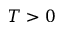<formula> <loc_0><loc_0><loc_500><loc_500>T > 0</formula> 